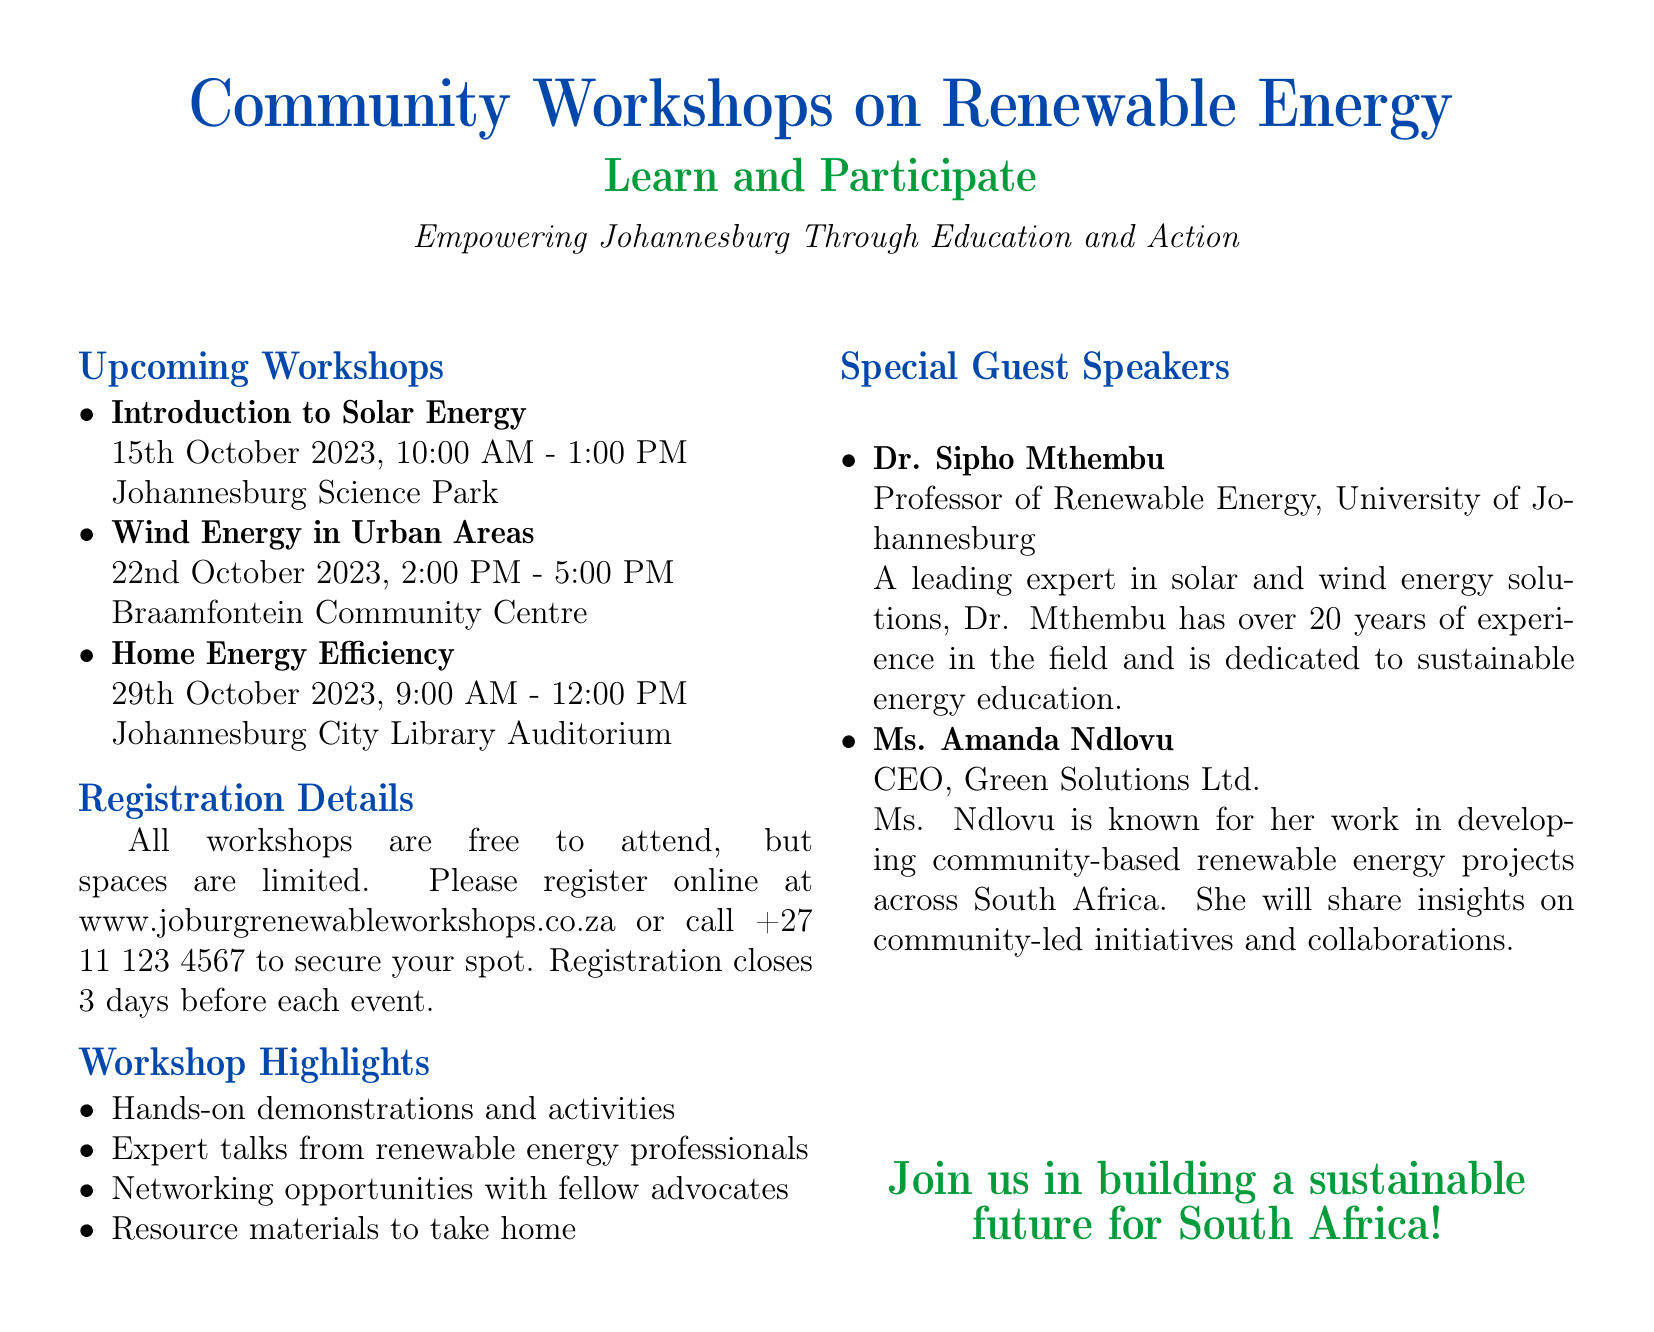What is the date for the "Introduction to Solar Energy" workshop? The date is explicitly mentioned in the list of upcoming workshops.
Answer: 15th October 2023 Where will the "Wind Energy in Urban Areas" workshop take place? The location is provided alongside each workshop title in the events schedule.
Answer: Braamfontein Community Centre What time does the "Home Energy Efficiency" workshop start? The time is stated in the upcoming workshops section.
Answer: 9:00 AM Are the workshops free to attend? The registration details clearly state whether there is a fee for attending the workshops.
Answer: Yes Who is the special guest speaker from the University of Johannesburg? The special guest speakers section names the individuals invited to speak at the workshops.
Answer: Dr. Sipho Mthembu What is the online registration website for the workshops? The registration details include the specific website for signing up for the events.
Answer: www.joburgrenewableworkshops.co.za What day does registration close before each event? Registration details mention the deadline for signing up for the workshops.
Answer: 3 days before each event What kind of materials will participants take home? The workshop highlights list the benefits and resources provided during the workshops.
Answer: Resource materials 